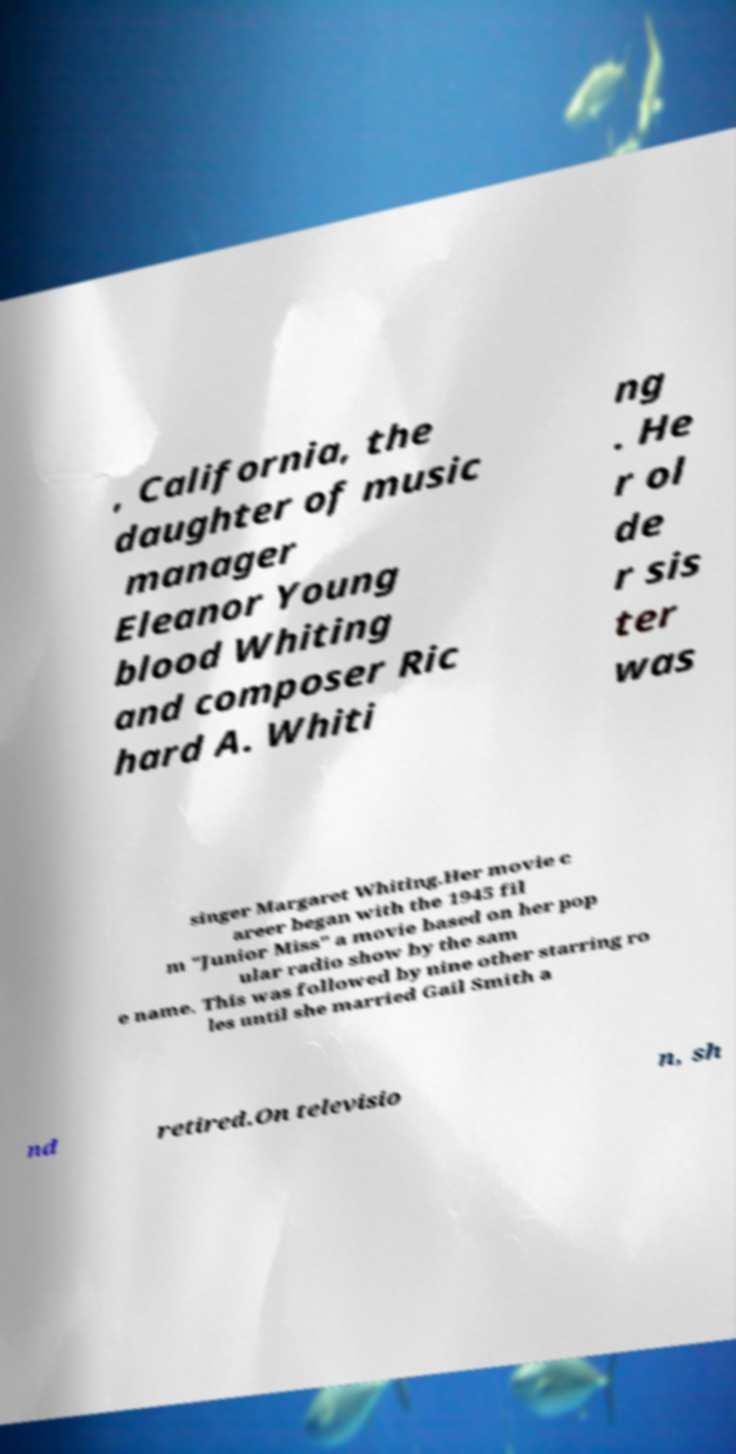Could you extract and type out the text from this image? , California, the daughter of music manager Eleanor Young blood Whiting and composer Ric hard A. Whiti ng . He r ol de r sis ter was singer Margaret Whiting.Her movie c areer began with the 1945 fil m "Junior Miss" a movie based on her pop ular radio show by the sam e name. This was followed by nine other starring ro les until she married Gail Smith a nd retired.On televisio n, sh 